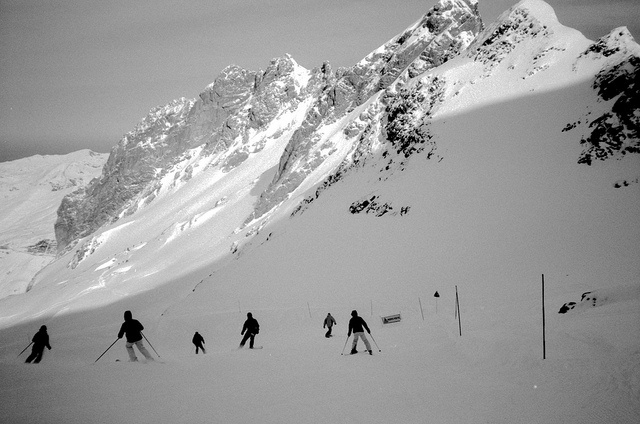Describe the objects in this image and their specific colors. I can see people in gray, black, and dimgray tones, people in dimgray, black, gray, darkgray, and lightgray tones, people in black, gray, and dimgray tones, people in dimgray, black, darkgray, gray, and lightgray tones, and people in gray, black, darkgray, and dimgray tones in this image. 